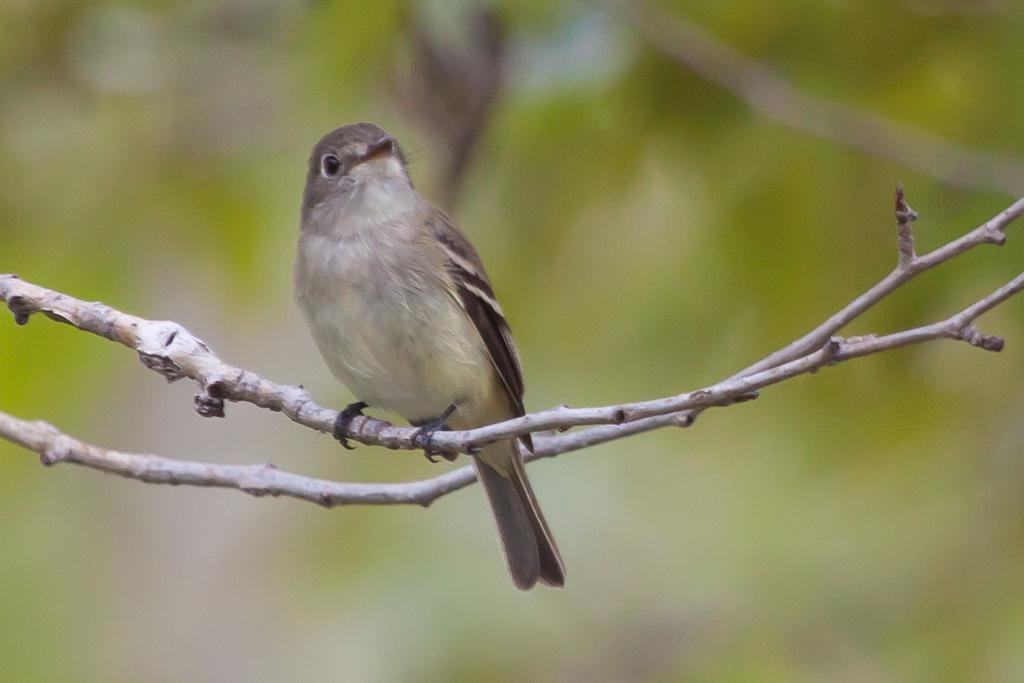Please provide a concise description of this image. In this picture we can see a bird on a stem. We can see another stem. Background is blurry. 